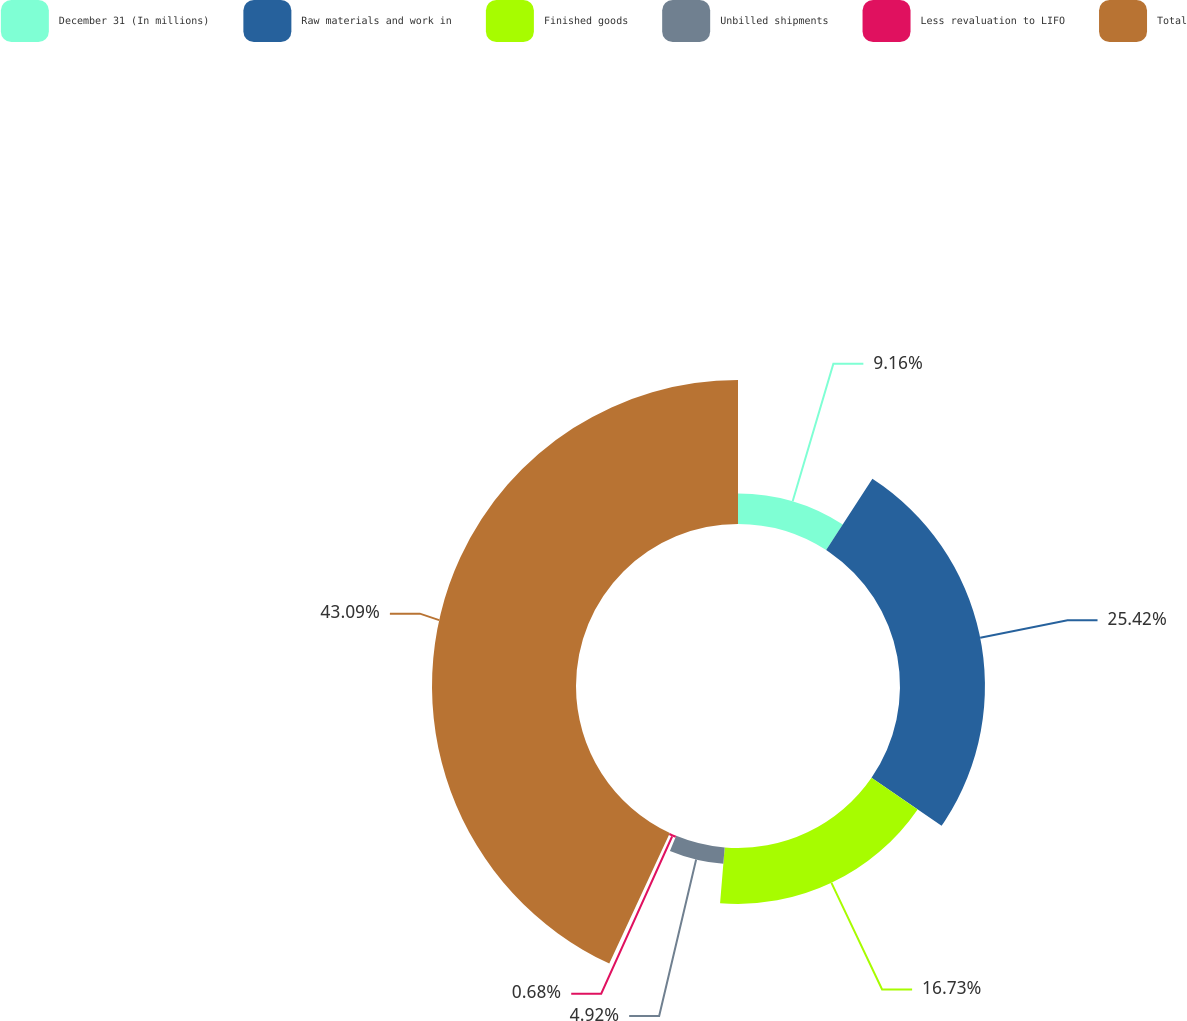Convert chart to OTSL. <chart><loc_0><loc_0><loc_500><loc_500><pie_chart><fcel>December 31 (In millions)<fcel>Raw materials and work in<fcel>Finished goods<fcel>Unbilled shipments<fcel>Less revaluation to LIFO<fcel>Total<nl><fcel>9.16%<fcel>25.42%<fcel>16.73%<fcel>4.92%<fcel>0.68%<fcel>43.09%<nl></chart> 